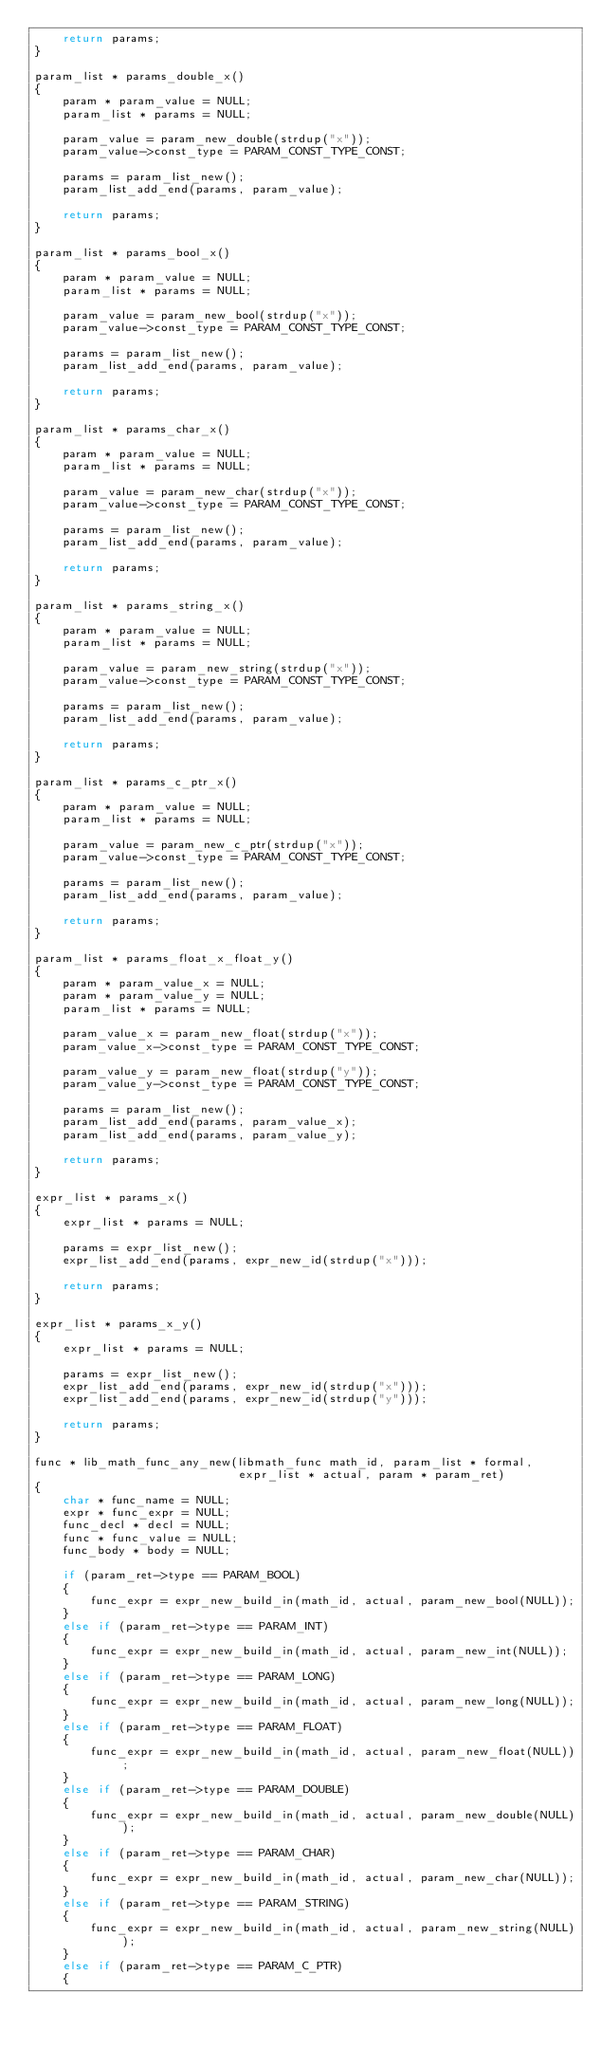<code> <loc_0><loc_0><loc_500><loc_500><_C_>    return params;
}

param_list * params_double_x()
{
    param * param_value = NULL;
    param_list * params = NULL;

    param_value = param_new_double(strdup("x"));
    param_value->const_type = PARAM_CONST_TYPE_CONST;

    params = param_list_new();
    param_list_add_end(params, param_value);

    return params;
}

param_list * params_bool_x()
{
    param * param_value = NULL;
    param_list * params = NULL;

    param_value = param_new_bool(strdup("x"));
    param_value->const_type = PARAM_CONST_TYPE_CONST;

    params = param_list_new();
    param_list_add_end(params, param_value);
    
    return params;
}

param_list * params_char_x()
{
    param * param_value = NULL;
    param_list * params = NULL;

    param_value = param_new_char(strdup("x"));
    param_value->const_type = PARAM_CONST_TYPE_CONST;

    params = param_list_new();
    param_list_add_end(params, param_value);
    
    return params;
}

param_list * params_string_x()
{
    param * param_value = NULL;
    param_list * params = NULL;

    param_value = param_new_string(strdup("x"));
    param_value->const_type = PARAM_CONST_TYPE_CONST;

    params = param_list_new();
    param_list_add_end(params, param_value);
    
    return params;
}

param_list * params_c_ptr_x()
{
    param * param_value = NULL;
    param_list * params = NULL;

    param_value = param_new_c_ptr(strdup("x"));
    param_value->const_type = PARAM_CONST_TYPE_CONST;

    params = param_list_new();
    param_list_add_end(params, param_value);
    
    return params;
}

param_list * params_float_x_float_y()
{
    param * param_value_x = NULL;
    param * param_value_y = NULL;
    param_list * params = NULL;

    param_value_x = param_new_float(strdup("x"));
    param_value_x->const_type = PARAM_CONST_TYPE_CONST;

    param_value_y = param_new_float(strdup("y"));
    param_value_y->const_type = PARAM_CONST_TYPE_CONST;

    params = param_list_new();
    param_list_add_end(params, param_value_x);
    param_list_add_end(params, param_value_y);

    return params;
}

expr_list * params_x()
{
    expr_list * params = NULL;

    params = expr_list_new();
    expr_list_add_end(params, expr_new_id(strdup("x")));

    return params;
}

expr_list * params_x_y()
{
    expr_list * params = NULL;

    params = expr_list_new();
    expr_list_add_end(params, expr_new_id(strdup("x")));
    expr_list_add_end(params, expr_new_id(strdup("y")));

    return params;
}

func * lib_math_func_any_new(libmath_func math_id, param_list * formal,
                             expr_list * actual, param * param_ret)
{
    char * func_name = NULL;
    expr * func_expr = NULL;
    func_decl * decl = NULL;
    func * func_value = NULL;
    func_body * body = NULL;

    if (param_ret->type == PARAM_BOOL)
    {
        func_expr = expr_new_build_in(math_id, actual, param_new_bool(NULL));
    }
    else if (param_ret->type == PARAM_INT)
    {
        func_expr = expr_new_build_in(math_id, actual, param_new_int(NULL));
    }
    else if (param_ret->type == PARAM_LONG)
    {
        func_expr = expr_new_build_in(math_id, actual, param_new_long(NULL));
    }
    else if (param_ret->type == PARAM_FLOAT)
    {
        func_expr = expr_new_build_in(math_id, actual, param_new_float(NULL));
    }
    else if (param_ret->type == PARAM_DOUBLE)
    {
        func_expr = expr_new_build_in(math_id, actual, param_new_double(NULL));
    }
    else if (param_ret->type == PARAM_CHAR)
    {
        func_expr = expr_new_build_in(math_id, actual, param_new_char(NULL));
    }
    else if (param_ret->type == PARAM_STRING)
    {
        func_expr = expr_new_build_in(math_id, actual, param_new_string(NULL));
    }
    else if (param_ret->type == PARAM_C_PTR)
    {</code> 